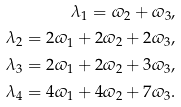<formula> <loc_0><loc_0><loc_500><loc_500>\lambda _ { 1 } = \varpi _ { 2 } + \varpi _ { 3 } , \\ \lambda _ { 2 } = 2 \varpi _ { 1 } + 2 \varpi _ { 2 } + 2 \varpi _ { 3 } , \\ \lambda _ { 3 } = 2 \varpi _ { 1 } + 2 \varpi _ { 2 } + 3 \varpi _ { 3 } , \\ \lambda _ { 4 } = 4 \varpi _ { 1 } + 4 \varpi _ { 2 } + 7 \varpi _ { 3 } .</formula> 